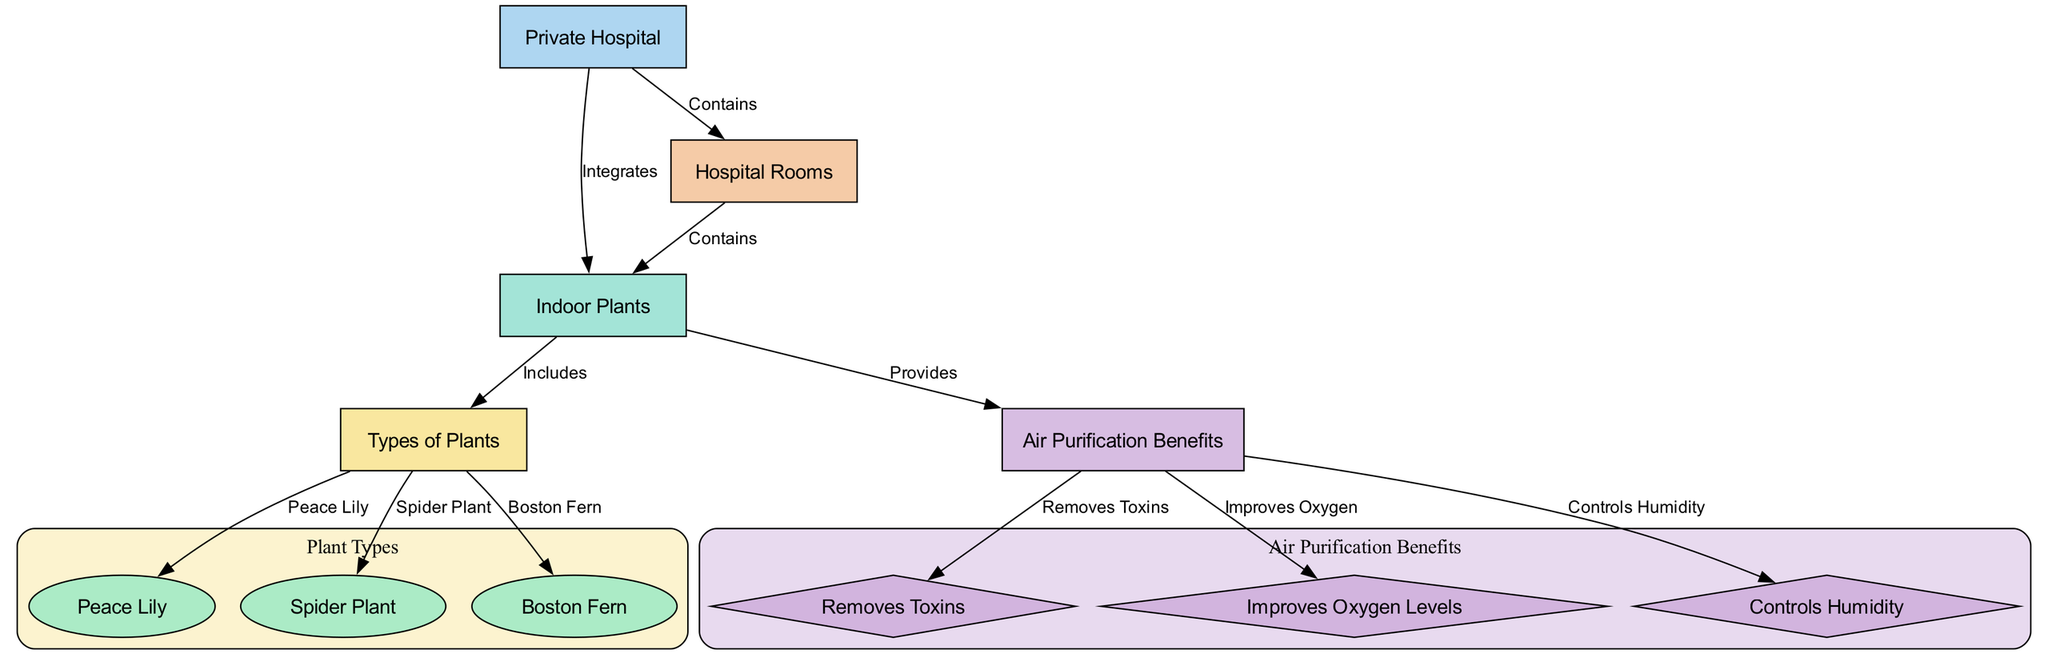What is the main entity depicted in the diagram? The main entity in the diagram is the "Private Hospital," which is the starting point of the ecosystem described.
Answer: Private Hospital How many types of indoor plants are shown in the diagram? There are three types of indoor plants identified in the diagram: Peace Lily, Spider Plant, and Boston Fern.
Answer: Three What benefit does the "Air Purification" node provide? The "Air Purification" node provides three benefits, specifically removing toxins, improving oxygen levels, and controlling humidity.
Answer: Removes Toxins, Improves Oxygen, Controls Humidity Which specific plant is indicated to improve oxygen levels? The diagram does not specify which of the individual plants improves oxygen levels; however, they all contribute to air purification collectively, but "Improves Oxygen" directly connects to "Air Purification."
Answer: Improves Oxygen Levels What is the relationship between "Indoor Plants" and "Hospital Rooms"? The "Indoor Plants" node is located within "Hospital Rooms," indicating that hospital rooms contain indoor plants as part of the ecosystem.
Answer: Contains Which plant is NOT illustrated in the diagram? The diagram only includes Peace Lily, Spider Plant, and Boston Fern; therefore, any other plant type such as Aloe Vera or Snake Plant is not illustrated.
Answer: Aloe Vera (or any other non-listed plant) How does "Humidity Control" relate to "Indoor Plants"? The "Humidity Control" benefit flows from the "Air Purification," which is directly provided by "Indoor Plants," signifying that indoor plants help manage humidity levels in the hospital environment.
Answer: Controls Humidity What is the total number of edges in the diagram? Count the number of connections (edges) between the nodes in the diagram; there are ten edges that connect these different entities.
Answer: Ten 